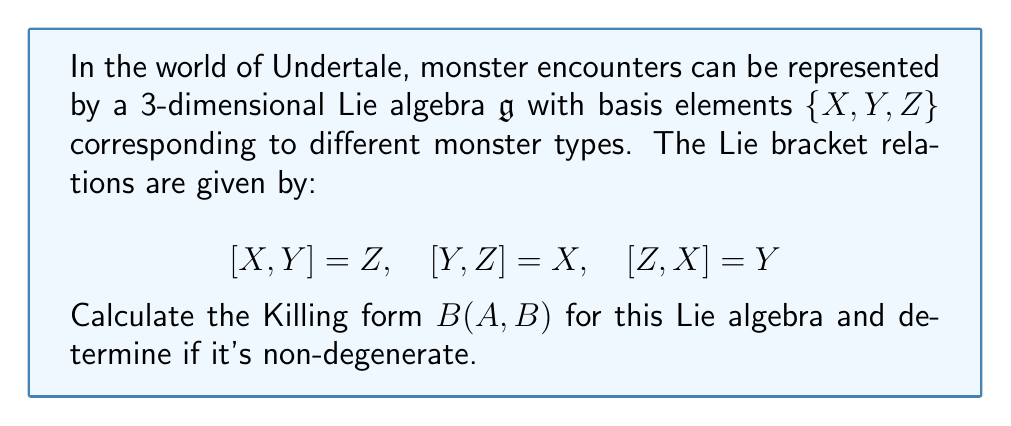Show me your answer to this math problem. To calculate the Killing form for this Lie algebra, we'll follow these steps:

1) The Killing form is defined as $B(A, B) = \text{tr}(\text{ad}_A \circ \text{ad}_B)$, where $\text{ad}_A$ is the adjoint representation of $A$.

2) First, we need to find the matrix representations of $\text{ad}_X$, $\text{ad}_Y$, and $\text{ad}_Z$ with respect to the basis $\{X, Y, Z\}$:

   $\text{ad}_X = \begin{pmatrix} 0 & 0 & -1 \\ 0 & 0 & 1 \\ 1 & -1 & 0 \end{pmatrix}$

   $\text{ad}_Y = \begin{pmatrix} 0 & 0 & 1 \\ 0 & 0 & -1 \\ -1 & 1 & 0 \end{pmatrix}$

   $\text{ad}_Z = \begin{pmatrix} 0 & -1 & 0 \\ 1 & 0 & 0 \\ 0 & 0 & 0 \end{pmatrix}$

3) Now, we calculate $B(X,X)$, $B(Y,Y)$, and $B(Z,Z)$:

   $B(X,X) = \text{tr}(\text{ad}_X \circ \text{ad}_X) = \text{tr}\begin{pmatrix} -1 & -1 & 0 \\ 1 & 1 & 0 \\ 0 & 0 & -2 \end{pmatrix} = -2$

   $B(Y,Y) = \text{tr}(\text{ad}_Y \circ \text{ad}_Y) = \text{tr}\begin{pmatrix} -1 & -1 & 0 \\ 1 & 1 & 0 \\ 0 & 0 & -2 \end{pmatrix} = -2$

   $B(Z,Z) = \text{tr}(\text{ad}_Z \circ \text{ad}_Z) = \text{tr}\begin{pmatrix} -1 & 0 & 0 \\ 0 & -1 & 0 \\ 0 & 0 & 0 \end{pmatrix} = -2$

4) For the off-diagonal elements:

   $B(X,Y) = B(Y,X) = \text{tr}(\text{ad}_X \circ \text{ad}_Y) = \text{tr}\begin{pmatrix} 1 & -1 & 0 \\ -1 & 1 & 0 \\ 0 & 0 & -2 \end{pmatrix} = 0$

   $B(X,Z) = B(Z,X) = \text{tr}(\text{ad}_X \circ \text{ad}_Z) = \text{tr}\begin{pmatrix} 0 & 1 & 0 \\ 0 & 0 & -1 \\ -1 & 0 & 0 \end{pmatrix} = 0$

   $B(Y,Z) = B(Z,Y) = \text{tr}(\text{ad}_Y \circ \text{ad}_Z) = \text{tr}\begin{pmatrix} 0 & -1 & 0 \\ 0 & 0 & 1 \\ 1 & 0 & 0 \end{pmatrix} = 0$

5) Therefore, the Killing form matrix is:

   $B = \begin{pmatrix} -2 & 0 & 0 \\ 0 & -2 & 0 \\ 0 & 0 & -2 \end{pmatrix}$

6) The determinant of this matrix is $-8 \neq 0$, so the Killing form is non-degenerate.
Answer: The Killing form for the given Lie algebra is:

$$B = \begin{pmatrix} -2 & 0 & 0 \\ 0 & -2 & 0 \\ 0 & 0 & -2 \end{pmatrix}$$

It is non-degenerate. 